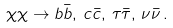Convert formula to latex. <formula><loc_0><loc_0><loc_500><loc_500>\chi \chi \rightarrow b \bar { b } , \, c \bar { c } , \, \tau \bar { \tau } , \, \nu \bar { \nu } \, .</formula> 